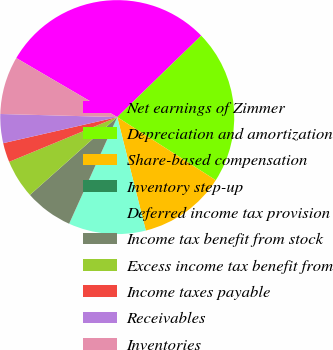Convert chart to OTSL. <chart><loc_0><loc_0><loc_500><loc_500><pie_chart><fcel>Net earnings of Zimmer<fcel>Depreciation and amortization<fcel>Share-based compensation<fcel>Inventory step-up<fcel>Deferred income tax provision<fcel>Income tax benefit from stock<fcel>Excess income tax benefit from<fcel>Income taxes payable<fcel>Receivables<fcel>Inventories<nl><fcel>29.32%<fcel>21.33%<fcel>12.0%<fcel>0.01%<fcel>10.67%<fcel>6.67%<fcel>5.34%<fcel>2.67%<fcel>4.0%<fcel>8.0%<nl></chart> 